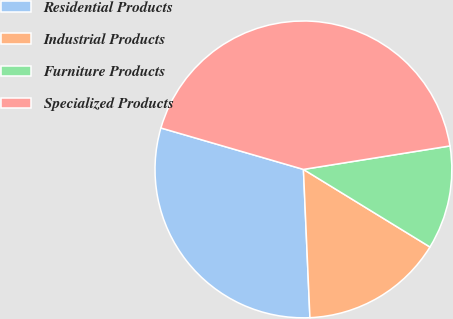Convert chart. <chart><loc_0><loc_0><loc_500><loc_500><pie_chart><fcel>Residential Products<fcel>Industrial Products<fcel>Furniture Products<fcel>Specialized Products<nl><fcel>30.2%<fcel>15.55%<fcel>11.28%<fcel>42.97%<nl></chart> 